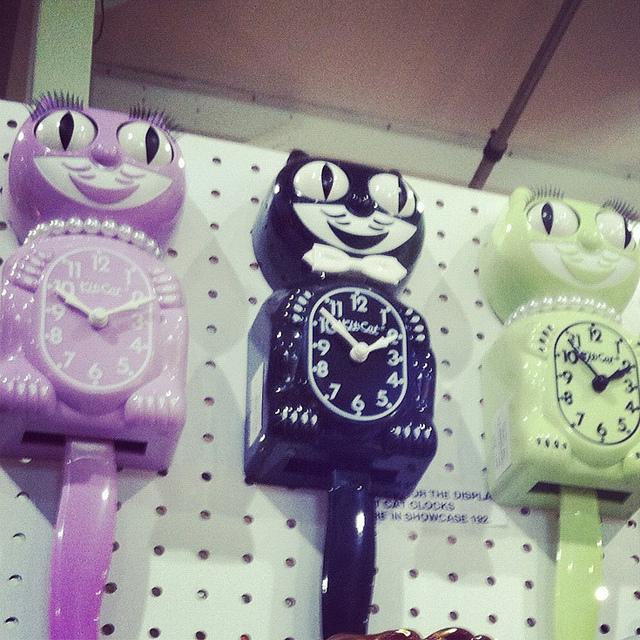What animal do the clocks look like?
Keep it brief. Cat. How can you tell the cats on each side are female?
Be succinct. Eyelashes. Do all clocks show the same time?
Quick response, please. Yes. What time is it in the picture?
Keep it brief. 1:50. What is the clock hanging on?
Write a very short answer. Pegboard. 